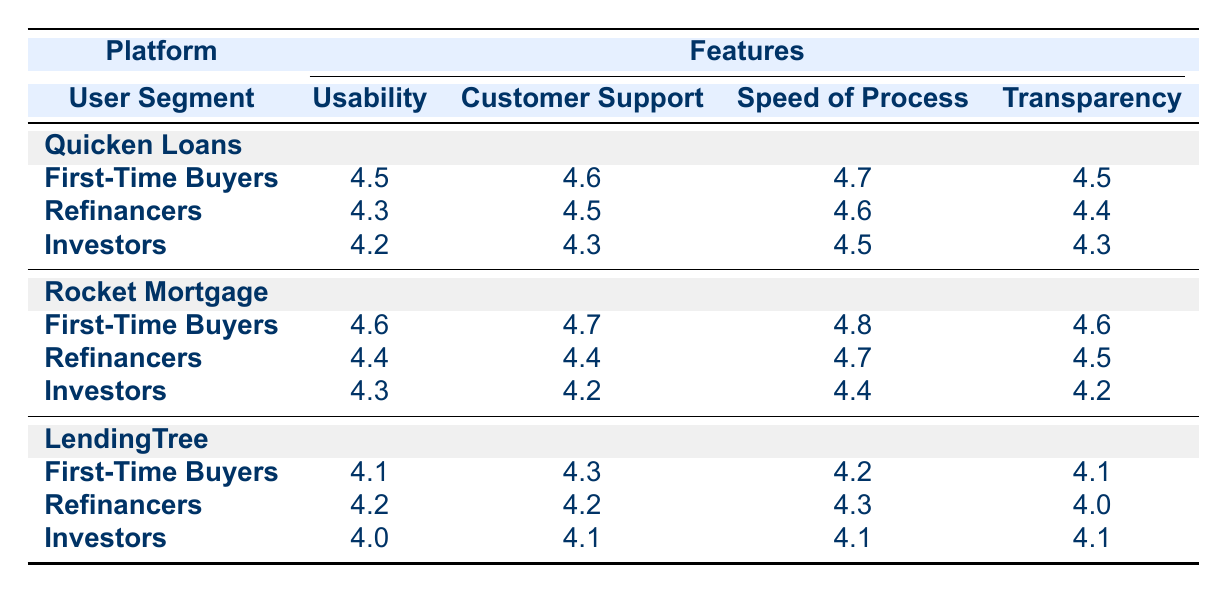What is the highest customer support rating for First-Time Buyers across all platforms? The customer support ratings for First-Time Buyers are 4.6 for Quicken Loans, 4.7 for Rocket Mortgage, and 4.3 for LendingTree. The highest among these is 4.7.
Answer: 4.7 Which platform has the lowest usability rating for Investors? The usability ratings for Investors are 4.2 for Quicken Loans, 4.3 for Rocket Mortgage, and 4.0 for LendingTree. The lowest among these is 4.0 for LendingTree.
Answer: LendingTree What is the average speed of the process rating for Refinancers across all platforms? The speed of process ratings for Refinancers are 4.6 for Quicken Loans, 4.7 for Rocket Mortgage, and 4.3 for LendingTree. The average is calculated as (4.6 + 4.7 + 4.3) / 3 = 4.533, approximately 4.5.
Answer: 4.5 Did Quicken Loans provide better transparency than LendingTree for Refencers? The transparency ratings for Refinancers are 4.4 for Quicken Loans and 4.0 for LendingTree. Since 4.4 is greater than 4.0, the statement is true.
Answer: Yes Which user segment has the highest overall satisfaction ratings across all features for Rocket Mortgage? The ratings for each user segment on Rocket Mortgage are: First-Time Buyers (4.6 + 4.7 + 4.8 + 4.6 = 18.7), Refinancers (4.4 + 4.4 + 4.7 + 4.5 = 18.0), and Investors (4.3 + 4.2 + 4.4 + 4.2 = 17.1). First-Time Buyers have the highest total of 18.7.
Answer: First-Time Buyers 